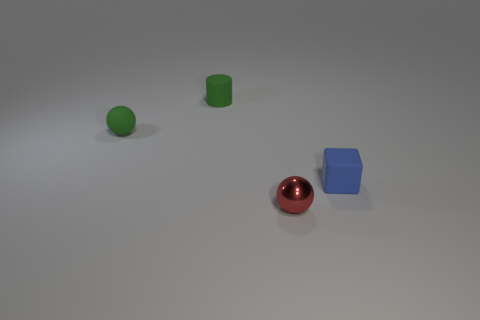What number of objects are the same color as the small matte ball?
Offer a terse response. 1. What is the size of the rubber object that is the same color as the cylinder?
Offer a very short reply. Small. Is there a red sphere that has the same material as the green sphere?
Keep it short and to the point. No. Are there more small cyan rubber things than small red metallic objects?
Offer a terse response. No. Are the green sphere and the small block made of the same material?
Your answer should be compact. Yes. How many shiny objects are red balls or tiny green balls?
Offer a terse response. 1. The shiny sphere that is the same size as the green matte cylinder is what color?
Ensure brevity in your answer.  Red. How many rubber things have the same shape as the metal thing?
Provide a succinct answer. 1. What number of cylinders are tiny objects or matte things?
Ensure brevity in your answer.  1. Is the shape of the object that is on the right side of the small red ball the same as the tiny object that is in front of the blue rubber object?
Ensure brevity in your answer.  No. 